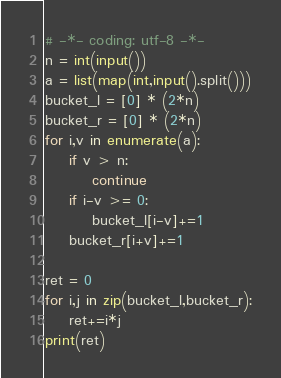<code> <loc_0><loc_0><loc_500><loc_500><_Python_># -*- coding: utf-8 -*-
n = int(input())
a = list(map(int,input().split()))
bucket_l = [0] * (2*n)
bucket_r = [0] * (2*n)
for i,v in enumerate(a):
    if v > n:
        continue
    if i-v >= 0:
        bucket_l[i-v]+=1
    bucket_r[i+v]+=1

ret = 0
for i,j in zip(bucket_l,bucket_r):
    ret+=i*j
print(ret)</code> 